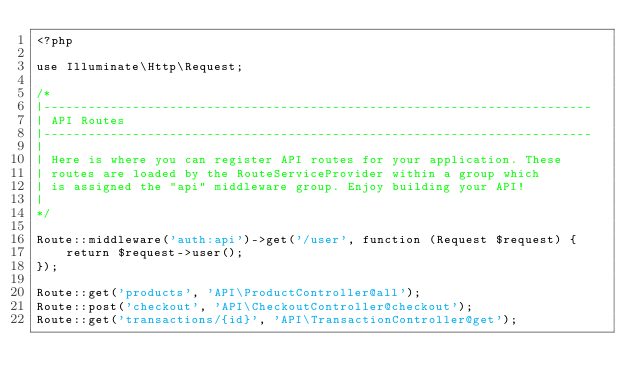Convert code to text. <code><loc_0><loc_0><loc_500><loc_500><_PHP_><?php

use Illuminate\Http\Request;

/*
|--------------------------------------------------------------------------
| API Routes
|--------------------------------------------------------------------------
|
| Here is where you can register API routes for your application. These
| routes are loaded by the RouteServiceProvider within a group which
| is assigned the "api" middleware group. Enjoy building your API!
|
*/

Route::middleware('auth:api')->get('/user', function (Request $request) {
    return $request->user();
});

Route::get('products', 'API\ProductController@all');
Route::post('checkout', 'API\CheckoutController@checkout');
Route::get('transactions/{id}', 'API\TransactionController@get');
</code> 